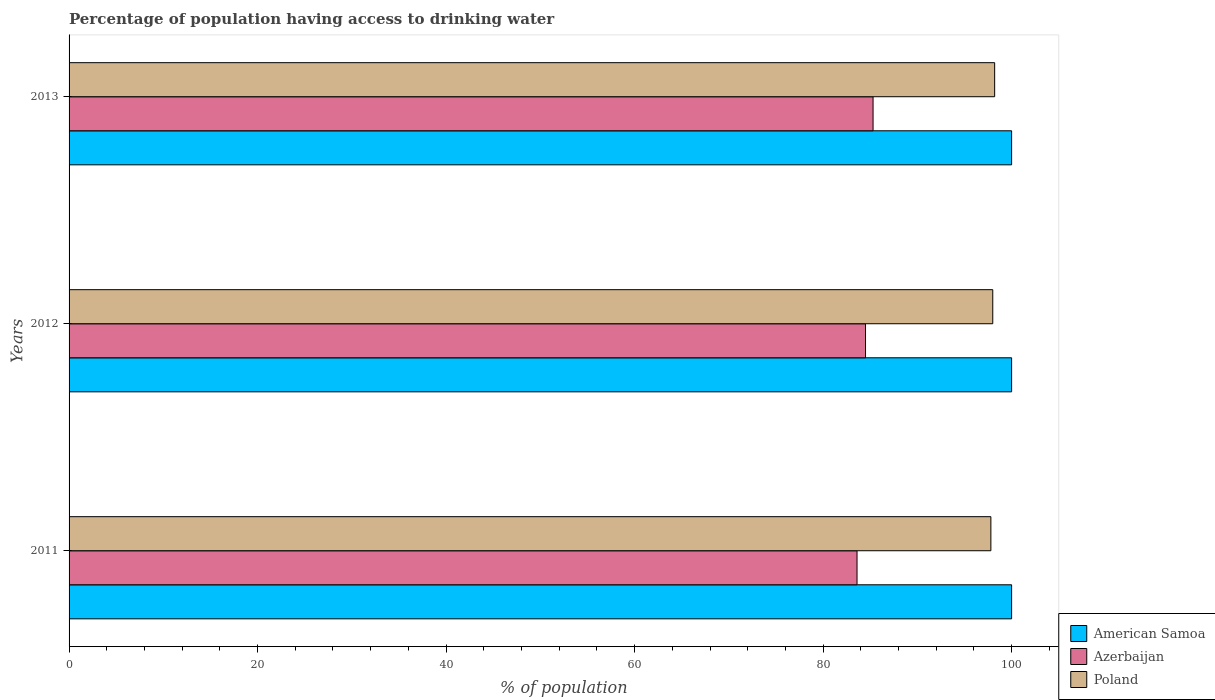How many different coloured bars are there?
Give a very brief answer. 3. Are the number of bars per tick equal to the number of legend labels?
Your response must be concise. Yes. How many bars are there on the 1st tick from the bottom?
Offer a terse response. 3. What is the percentage of population having access to drinking water in Poland in 2013?
Provide a short and direct response. 98.2. Across all years, what is the maximum percentage of population having access to drinking water in Azerbaijan?
Your answer should be compact. 85.3. In which year was the percentage of population having access to drinking water in American Samoa maximum?
Make the answer very short. 2011. What is the total percentage of population having access to drinking water in Azerbaijan in the graph?
Ensure brevity in your answer.  253.4. What is the difference between the percentage of population having access to drinking water in Poland in 2011 and that in 2012?
Provide a short and direct response. -0.2. What is the difference between the percentage of population having access to drinking water in Azerbaijan in 2011 and the percentage of population having access to drinking water in Poland in 2013?
Provide a succinct answer. -14.6. In the year 2013, what is the difference between the percentage of population having access to drinking water in American Samoa and percentage of population having access to drinking water in Poland?
Make the answer very short. 1.8. In how many years, is the percentage of population having access to drinking water in Azerbaijan greater than 92 %?
Provide a short and direct response. 0. What is the ratio of the percentage of population having access to drinking water in Azerbaijan in 2012 to that in 2013?
Offer a very short reply. 0.99. Is the difference between the percentage of population having access to drinking water in American Samoa in 2011 and 2012 greater than the difference between the percentage of population having access to drinking water in Poland in 2011 and 2012?
Make the answer very short. Yes. What is the difference between the highest and the second highest percentage of population having access to drinking water in Azerbaijan?
Provide a succinct answer. 0.8. What is the difference between the highest and the lowest percentage of population having access to drinking water in American Samoa?
Provide a succinct answer. 0. In how many years, is the percentage of population having access to drinking water in American Samoa greater than the average percentage of population having access to drinking water in American Samoa taken over all years?
Provide a succinct answer. 0. Is the sum of the percentage of population having access to drinking water in Azerbaijan in 2012 and 2013 greater than the maximum percentage of population having access to drinking water in American Samoa across all years?
Keep it short and to the point. Yes. What does the 3rd bar from the top in 2012 represents?
Your answer should be very brief. American Samoa. What does the 1st bar from the bottom in 2013 represents?
Offer a terse response. American Samoa. How many years are there in the graph?
Provide a succinct answer. 3. What is the difference between two consecutive major ticks on the X-axis?
Your response must be concise. 20. Does the graph contain any zero values?
Offer a very short reply. No. Does the graph contain grids?
Your response must be concise. No. Where does the legend appear in the graph?
Keep it short and to the point. Bottom right. How many legend labels are there?
Make the answer very short. 3. How are the legend labels stacked?
Offer a terse response. Vertical. What is the title of the graph?
Make the answer very short. Percentage of population having access to drinking water. Does "Channel Islands" appear as one of the legend labels in the graph?
Keep it short and to the point. No. What is the label or title of the X-axis?
Your answer should be compact. % of population. What is the label or title of the Y-axis?
Keep it short and to the point. Years. What is the % of population of American Samoa in 2011?
Provide a succinct answer. 100. What is the % of population in Azerbaijan in 2011?
Provide a succinct answer. 83.6. What is the % of population in Poland in 2011?
Keep it short and to the point. 97.8. What is the % of population of Azerbaijan in 2012?
Offer a terse response. 84.5. What is the % of population of Poland in 2012?
Your answer should be very brief. 98. What is the % of population in Azerbaijan in 2013?
Provide a short and direct response. 85.3. What is the % of population of Poland in 2013?
Give a very brief answer. 98.2. Across all years, what is the maximum % of population in Azerbaijan?
Your response must be concise. 85.3. Across all years, what is the maximum % of population of Poland?
Your answer should be compact. 98.2. Across all years, what is the minimum % of population in Azerbaijan?
Provide a short and direct response. 83.6. Across all years, what is the minimum % of population in Poland?
Your answer should be very brief. 97.8. What is the total % of population of American Samoa in the graph?
Offer a very short reply. 300. What is the total % of population in Azerbaijan in the graph?
Offer a very short reply. 253.4. What is the total % of population in Poland in the graph?
Keep it short and to the point. 294. What is the difference between the % of population of Azerbaijan in 2011 and that in 2012?
Ensure brevity in your answer.  -0.9. What is the difference between the % of population in Azerbaijan in 2011 and that in 2013?
Offer a very short reply. -1.7. What is the difference between the % of population of Poland in 2011 and that in 2013?
Keep it short and to the point. -0.4. What is the difference between the % of population in American Samoa in 2011 and the % of population in Poland in 2012?
Give a very brief answer. 2. What is the difference between the % of population in Azerbaijan in 2011 and the % of population in Poland in 2012?
Offer a very short reply. -14.4. What is the difference between the % of population in American Samoa in 2011 and the % of population in Poland in 2013?
Provide a short and direct response. 1.8. What is the difference between the % of population in Azerbaijan in 2011 and the % of population in Poland in 2013?
Your answer should be compact. -14.6. What is the difference between the % of population of American Samoa in 2012 and the % of population of Poland in 2013?
Provide a short and direct response. 1.8. What is the difference between the % of population of Azerbaijan in 2012 and the % of population of Poland in 2013?
Offer a very short reply. -13.7. What is the average % of population in Azerbaijan per year?
Ensure brevity in your answer.  84.47. In the year 2012, what is the difference between the % of population in American Samoa and % of population in Azerbaijan?
Offer a terse response. 15.5. In the year 2012, what is the difference between the % of population in Azerbaijan and % of population in Poland?
Make the answer very short. -13.5. In the year 2013, what is the difference between the % of population of American Samoa and % of population of Poland?
Your response must be concise. 1.8. In the year 2013, what is the difference between the % of population of Azerbaijan and % of population of Poland?
Provide a short and direct response. -12.9. What is the ratio of the % of population of Azerbaijan in 2011 to that in 2012?
Your answer should be compact. 0.99. What is the ratio of the % of population of American Samoa in 2011 to that in 2013?
Provide a short and direct response. 1. What is the ratio of the % of population of Azerbaijan in 2011 to that in 2013?
Give a very brief answer. 0.98. What is the ratio of the % of population of Poland in 2011 to that in 2013?
Offer a terse response. 1. What is the ratio of the % of population of American Samoa in 2012 to that in 2013?
Offer a very short reply. 1. What is the ratio of the % of population of Azerbaijan in 2012 to that in 2013?
Make the answer very short. 0.99. What is the difference between the highest and the second highest % of population of American Samoa?
Provide a short and direct response. 0. What is the difference between the highest and the second highest % of population of Poland?
Give a very brief answer. 0.2. What is the difference between the highest and the lowest % of population in Poland?
Offer a very short reply. 0.4. 